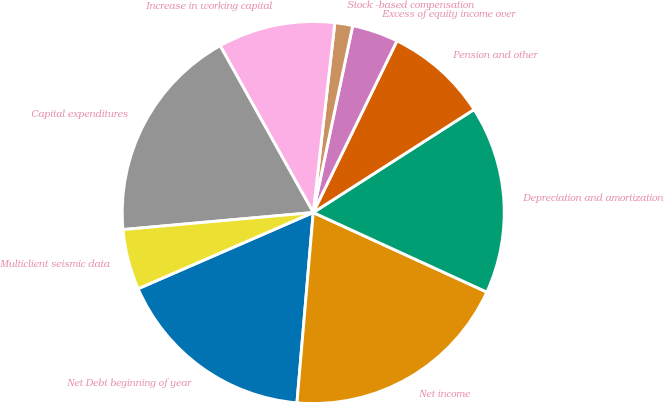Convert chart to OTSL. <chart><loc_0><loc_0><loc_500><loc_500><pie_chart><fcel>Net Debt beginning of year<fcel>Net income<fcel>Depreciation and amortization<fcel>Pension and other<fcel>Excess of equity income over<fcel>Stock -based compensation<fcel>Increase in working capital<fcel>Capital expenditures<fcel>Multiclient seismic data<nl><fcel>17.11%<fcel>19.52%<fcel>15.91%<fcel>8.71%<fcel>3.91%<fcel>1.51%<fcel>9.91%<fcel>18.32%<fcel>5.11%<nl></chart> 